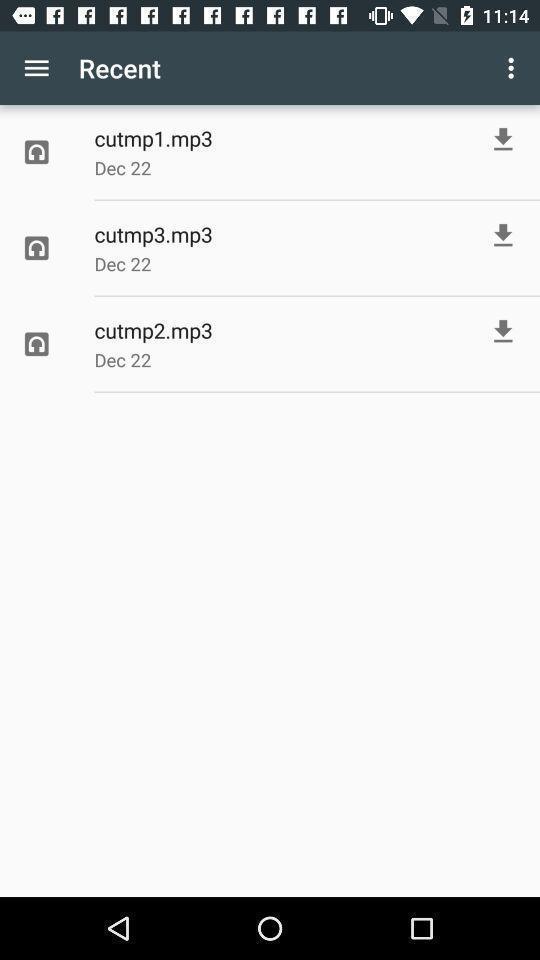Give me a summary of this screen capture. Screen displaying the recent downloads. 